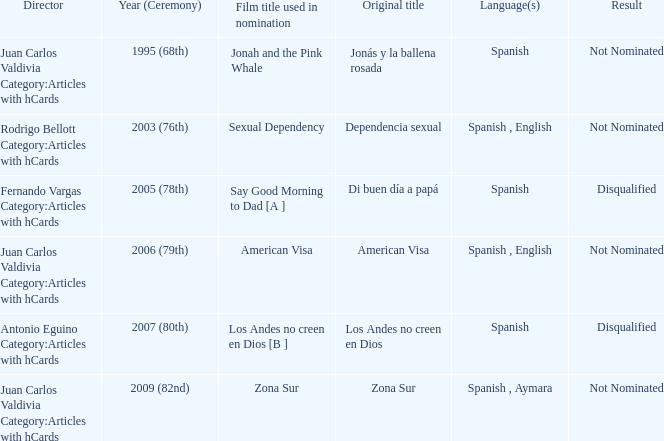What was Zona Sur's result after being considered for nomination? Not Nominated. 